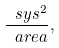<formula> <loc_0><loc_0><loc_500><loc_500>\frac { \ s y s ^ { 2 } } { \ a r e a } ,</formula> 